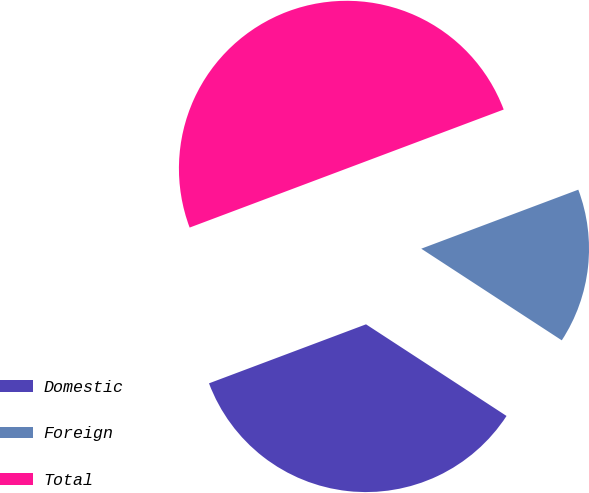Convert chart. <chart><loc_0><loc_0><loc_500><loc_500><pie_chart><fcel>Domestic<fcel>Foreign<fcel>Total<nl><fcel>35.08%<fcel>14.92%<fcel>50.0%<nl></chart> 